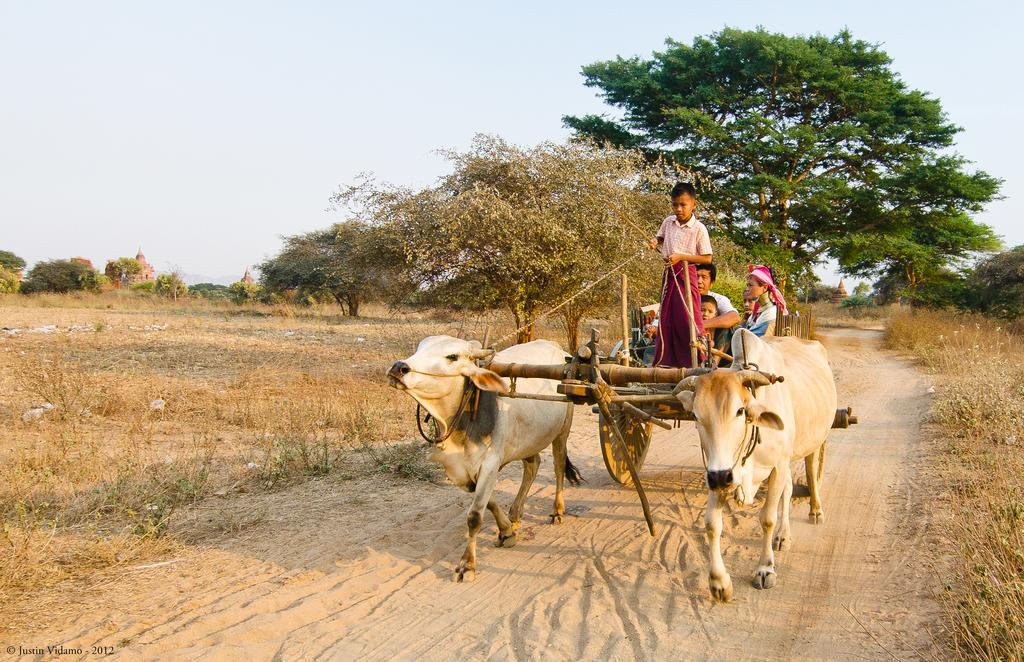What is on the ground in the image? There is a bullock cart on the ground. Who or what is on the bullock cart? There are persons on the bullock cart. What type of vegetation can be seen in the image? There are trees and grass in the image. What is visible in the background of the image? The sky is visible in the background of the image. Is there an umbrella being used by the persons on the bullock cart in the image? There is no mention of an umbrella in the image, so it cannot be determined if one is being used. 